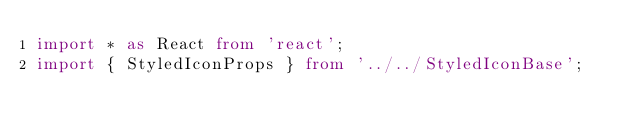<code> <loc_0><loc_0><loc_500><loc_500><_TypeScript_>import * as React from 'react';
import { StyledIconProps } from '../../StyledIconBase';</code> 